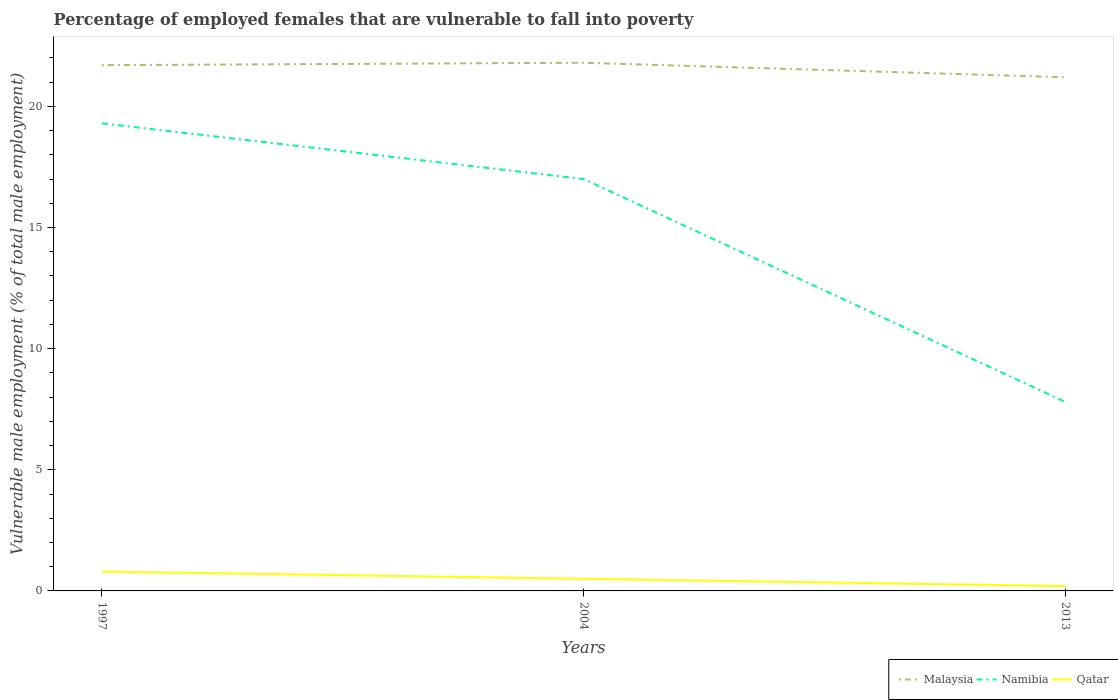How many different coloured lines are there?
Keep it short and to the point. 3. Is the number of lines equal to the number of legend labels?
Ensure brevity in your answer.  Yes. Across all years, what is the maximum percentage of employed females who are vulnerable to fall into poverty in Namibia?
Keep it short and to the point. 7.8. What is the total percentage of employed females who are vulnerable to fall into poverty in Qatar in the graph?
Give a very brief answer. 0.3. What is the difference between the highest and the second highest percentage of employed females who are vulnerable to fall into poverty in Namibia?
Keep it short and to the point. 11.5. What is the difference between the highest and the lowest percentage of employed females who are vulnerable to fall into poverty in Namibia?
Your answer should be compact. 2. Is the percentage of employed females who are vulnerable to fall into poverty in Malaysia strictly greater than the percentage of employed females who are vulnerable to fall into poverty in Namibia over the years?
Make the answer very short. No. How many lines are there?
Provide a short and direct response. 3. How many years are there in the graph?
Provide a succinct answer. 3. Are the values on the major ticks of Y-axis written in scientific E-notation?
Your answer should be very brief. No. Does the graph contain any zero values?
Your response must be concise. No. Where does the legend appear in the graph?
Your answer should be very brief. Bottom right. How are the legend labels stacked?
Your response must be concise. Horizontal. What is the title of the graph?
Offer a terse response. Percentage of employed females that are vulnerable to fall into poverty. What is the label or title of the X-axis?
Provide a succinct answer. Years. What is the label or title of the Y-axis?
Offer a terse response. Vulnerable male employment (% of total male employment). What is the Vulnerable male employment (% of total male employment) in Malaysia in 1997?
Your answer should be very brief. 21.7. What is the Vulnerable male employment (% of total male employment) in Namibia in 1997?
Your answer should be very brief. 19.3. What is the Vulnerable male employment (% of total male employment) in Qatar in 1997?
Make the answer very short. 0.8. What is the Vulnerable male employment (% of total male employment) in Malaysia in 2004?
Offer a very short reply. 21.8. What is the Vulnerable male employment (% of total male employment) of Qatar in 2004?
Keep it short and to the point. 0.5. What is the Vulnerable male employment (% of total male employment) of Malaysia in 2013?
Provide a succinct answer. 21.2. What is the Vulnerable male employment (% of total male employment) of Namibia in 2013?
Provide a succinct answer. 7.8. What is the Vulnerable male employment (% of total male employment) of Qatar in 2013?
Your answer should be compact. 0.2. Across all years, what is the maximum Vulnerable male employment (% of total male employment) of Malaysia?
Keep it short and to the point. 21.8. Across all years, what is the maximum Vulnerable male employment (% of total male employment) of Namibia?
Ensure brevity in your answer.  19.3. Across all years, what is the maximum Vulnerable male employment (% of total male employment) in Qatar?
Ensure brevity in your answer.  0.8. Across all years, what is the minimum Vulnerable male employment (% of total male employment) of Malaysia?
Keep it short and to the point. 21.2. Across all years, what is the minimum Vulnerable male employment (% of total male employment) in Namibia?
Your answer should be compact. 7.8. Across all years, what is the minimum Vulnerable male employment (% of total male employment) in Qatar?
Your response must be concise. 0.2. What is the total Vulnerable male employment (% of total male employment) of Malaysia in the graph?
Your answer should be compact. 64.7. What is the total Vulnerable male employment (% of total male employment) of Namibia in the graph?
Provide a short and direct response. 44.1. What is the total Vulnerable male employment (% of total male employment) in Qatar in the graph?
Make the answer very short. 1.5. What is the difference between the Vulnerable male employment (% of total male employment) of Malaysia in 1997 and that in 2004?
Provide a succinct answer. -0.1. What is the difference between the Vulnerable male employment (% of total male employment) in Malaysia in 1997 and that in 2013?
Provide a succinct answer. 0.5. What is the difference between the Vulnerable male employment (% of total male employment) of Qatar in 2004 and that in 2013?
Offer a very short reply. 0.3. What is the difference between the Vulnerable male employment (% of total male employment) in Malaysia in 1997 and the Vulnerable male employment (% of total male employment) in Namibia in 2004?
Ensure brevity in your answer.  4.7. What is the difference between the Vulnerable male employment (% of total male employment) of Malaysia in 1997 and the Vulnerable male employment (% of total male employment) of Qatar in 2004?
Offer a terse response. 21.2. What is the difference between the Vulnerable male employment (% of total male employment) of Namibia in 1997 and the Vulnerable male employment (% of total male employment) of Qatar in 2004?
Keep it short and to the point. 18.8. What is the difference between the Vulnerable male employment (% of total male employment) in Malaysia in 1997 and the Vulnerable male employment (% of total male employment) in Namibia in 2013?
Give a very brief answer. 13.9. What is the difference between the Vulnerable male employment (% of total male employment) of Malaysia in 1997 and the Vulnerable male employment (% of total male employment) of Qatar in 2013?
Provide a succinct answer. 21.5. What is the difference between the Vulnerable male employment (% of total male employment) of Malaysia in 2004 and the Vulnerable male employment (% of total male employment) of Namibia in 2013?
Provide a short and direct response. 14. What is the difference between the Vulnerable male employment (% of total male employment) in Malaysia in 2004 and the Vulnerable male employment (% of total male employment) in Qatar in 2013?
Give a very brief answer. 21.6. What is the difference between the Vulnerable male employment (% of total male employment) in Namibia in 2004 and the Vulnerable male employment (% of total male employment) in Qatar in 2013?
Give a very brief answer. 16.8. What is the average Vulnerable male employment (% of total male employment) of Malaysia per year?
Provide a short and direct response. 21.57. In the year 1997, what is the difference between the Vulnerable male employment (% of total male employment) in Malaysia and Vulnerable male employment (% of total male employment) in Namibia?
Your response must be concise. 2.4. In the year 1997, what is the difference between the Vulnerable male employment (% of total male employment) of Malaysia and Vulnerable male employment (% of total male employment) of Qatar?
Ensure brevity in your answer.  20.9. In the year 2004, what is the difference between the Vulnerable male employment (% of total male employment) in Malaysia and Vulnerable male employment (% of total male employment) in Namibia?
Provide a short and direct response. 4.8. In the year 2004, what is the difference between the Vulnerable male employment (% of total male employment) of Malaysia and Vulnerable male employment (% of total male employment) of Qatar?
Make the answer very short. 21.3. In the year 2004, what is the difference between the Vulnerable male employment (% of total male employment) of Namibia and Vulnerable male employment (% of total male employment) of Qatar?
Give a very brief answer. 16.5. In the year 2013, what is the difference between the Vulnerable male employment (% of total male employment) of Malaysia and Vulnerable male employment (% of total male employment) of Namibia?
Keep it short and to the point. 13.4. In the year 2013, what is the difference between the Vulnerable male employment (% of total male employment) in Malaysia and Vulnerable male employment (% of total male employment) in Qatar?
Provide a succinct answer. 21. What is the ratio of the Vulnerable male employment (% of total male employment) in Namibia in 1997 to that in 2004?
Provide a short and direct response. 1.14. What is the ratio of the Vulnerable male employment (% of total male employment) in Malaysia in 1997 to that in 2013?
Ensure brevity in your answer.  1.02. What is the ratio of the Vulnerable male employment (% of total male employment) of Namibia in 1997 to that in 2013?
Provide a succinct answer. 2.47. What is the ratio of the Vulnerable male employment (% of total male employment) of Qatar in 1997 to that in 2013?
Provide a succinct answer. 4. What is the ratio of the Vulnerable male employment (% of total male employment) in Malaysia in 2004 to that in 2013?
Keep it short and to the point. 1.03. What is the ratio of the Vulnerable male employment (% of total male employment) in Namibia in 2004 to that in 2013?
Make the answer very short. 2.18. What is the difference between the highest and the second highest Vulnerable male employment (% of total male employment) in Namibia?
Your answer should be compact. 2.3. What is the difference between the highest and the lowest Vulnerable male employment (% of total male employment) of Malaysia?
Provide a short and direct response. 0.6. What is the difference between the highest and the lowest Vulnerable male employment (% of total male employment) of Namibia?
Provide a succinct answer. 11.5. What is the difference between the highest and the lowest Vulnerable male employment (% of total male employment) of Qatar?
Keep it short and to the point. 0.6. 